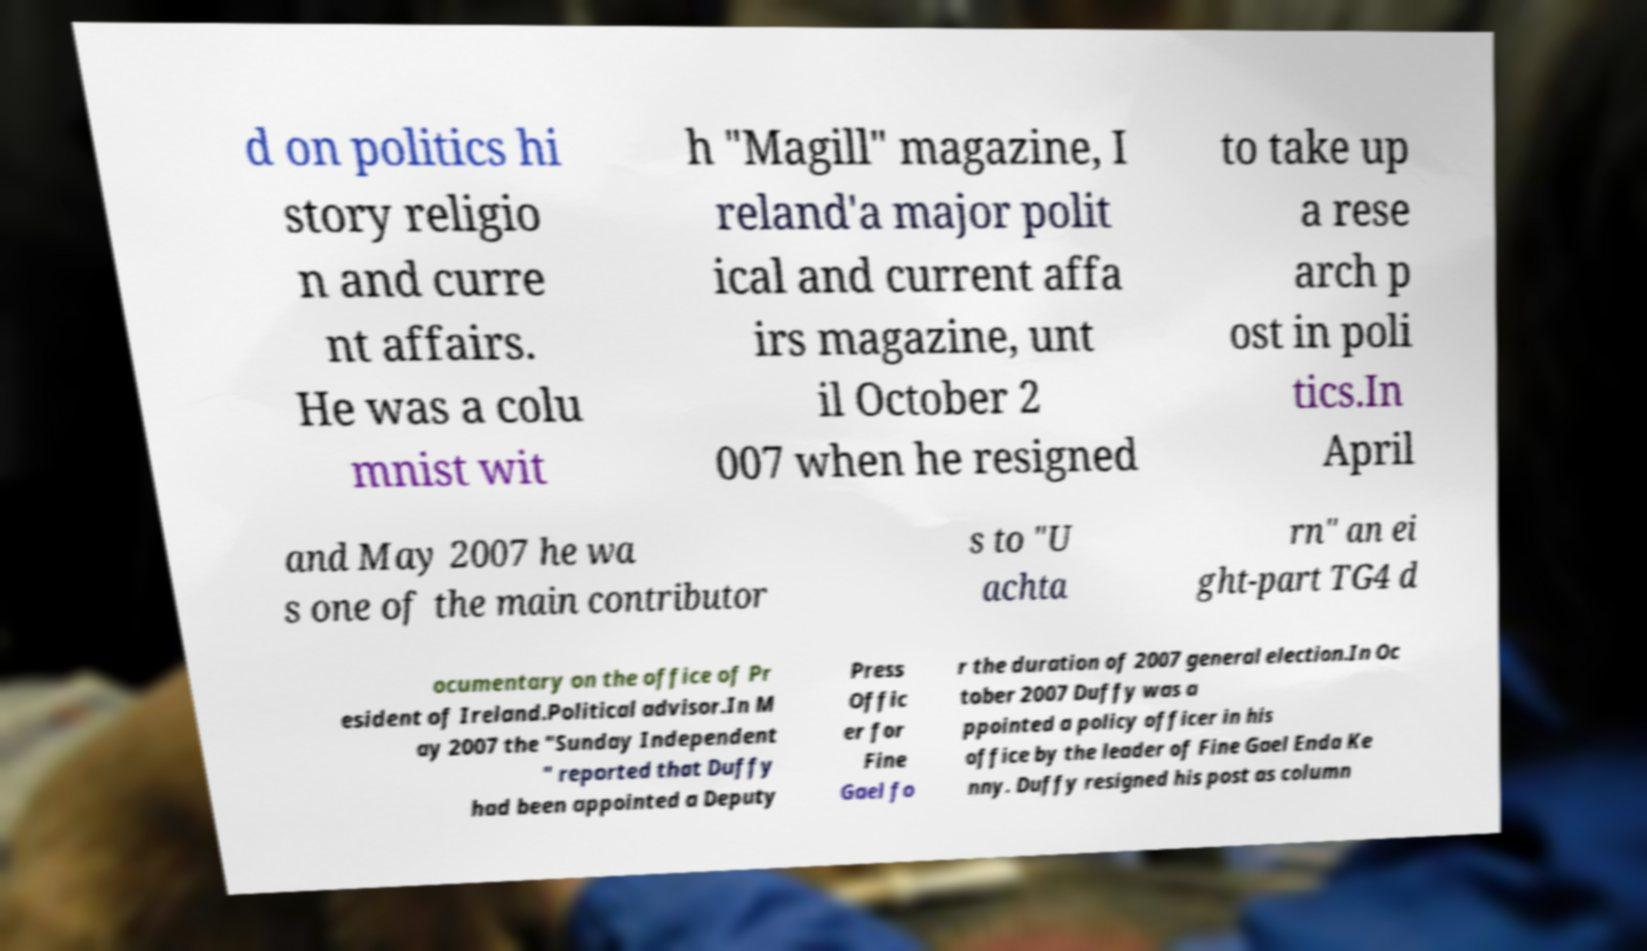What messages or text are displayed in this image? I need them in a readable, typed format. d on politics hi story religio n and curre nt affairs. He was a colu mnist wit h "Magill" magazine, I reland'a major polit ical and current affa irs magazine, unt il October 2 007 when he resigned to take up a rese arch p ost in poli tics.In April and May 2007 he wa s one of the main contributor s to "U achta rn" an ei ght-part TG4 d ocumentary on the office of Pr esident of Ireland.Political advisor.In M ay 2007 the "Sunday Independent " reported that Duffy had been appointed a Deputy Press Offic er for Fine Gael fo r the duration of 2007 general election.In Oc tober 2007 Duffy was a ppointed a policy officer in his office by the leader of Fine Gael Enda Ke nny. Duffy resigned his post as column 